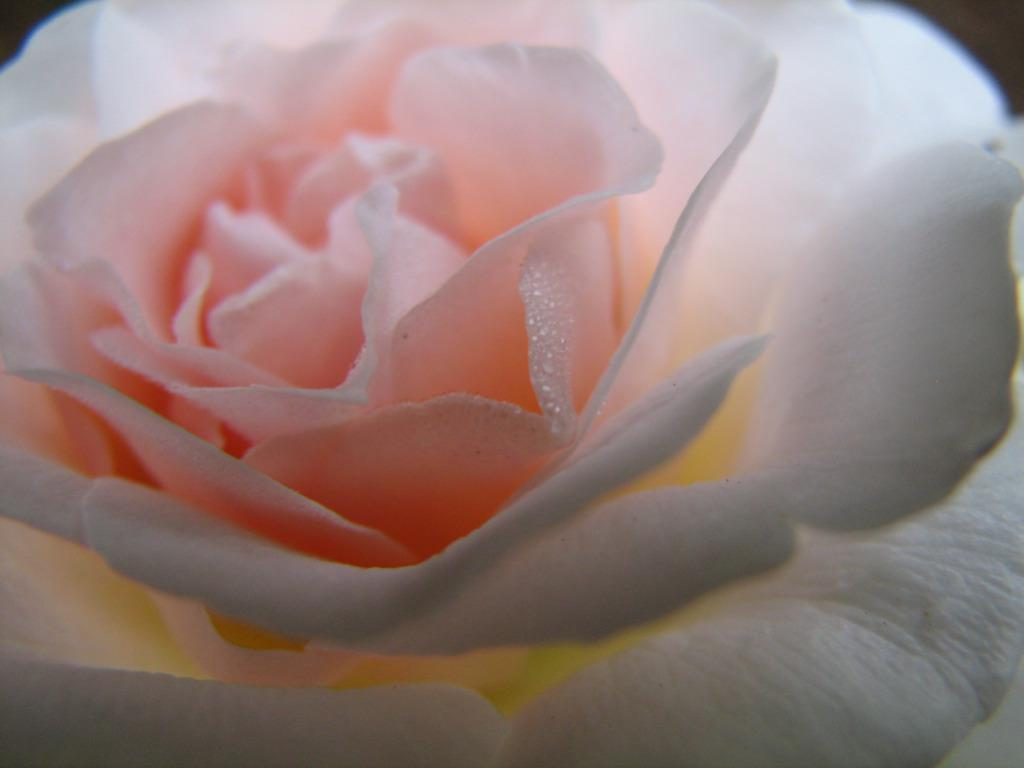What is the main subject of the image? The main subject of the image is a flower. Can you describe the flower in more detail? Yes, the flower has petals. What type of house is depicted in the image? There is no house present in the image; it features a flower with petals. What is being served for dinner in the image? There is no dinner being served in the image; it features a flower with petals. 